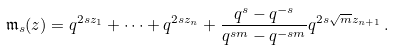<formula> <loc_0><loc_0><loc_500><loc_500>\mathfrak m _ { s } ( z ) = q ^ { 2 s z _ { 1 } } + \dots + q ^ { 2 s z _ { n } } + \frac { q ^ { s } - q ^ { - s } } { q ^ { s m } - q ^ { - s m } } q ^ { 2 s \sqrt { m } z _ { n + 1 } } \, .</formula> 